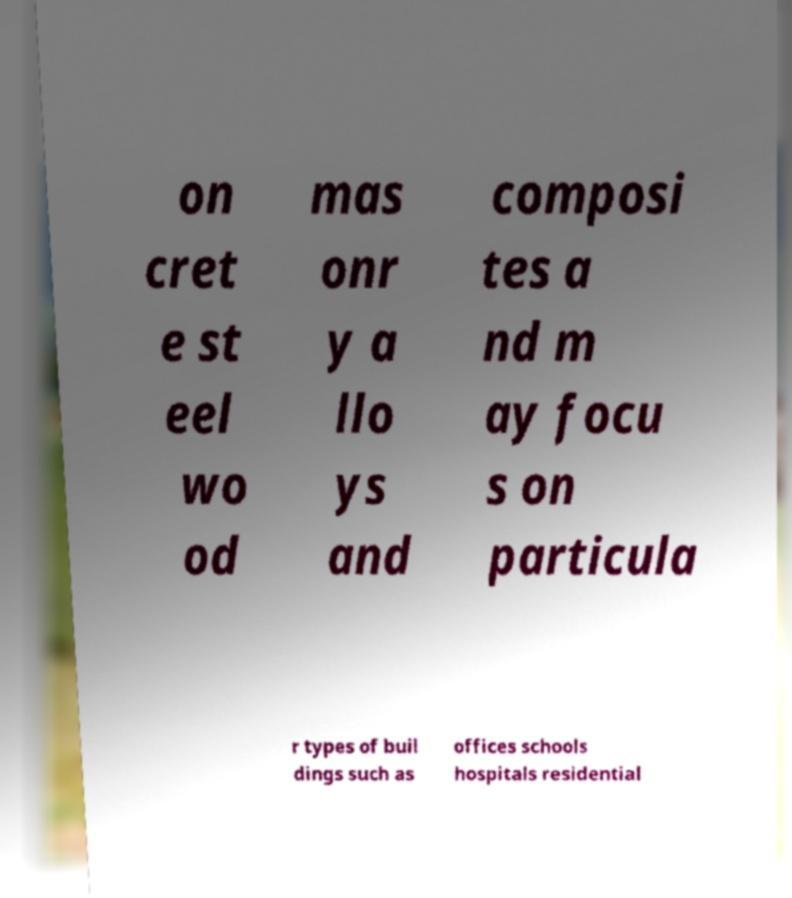Could you extract and type out the text from this image? on cret e st eel wo od mas onr y a llo ys and composi tes a nd m ay focu s on particula r types of buil dings such as offices schools hospitals residential 